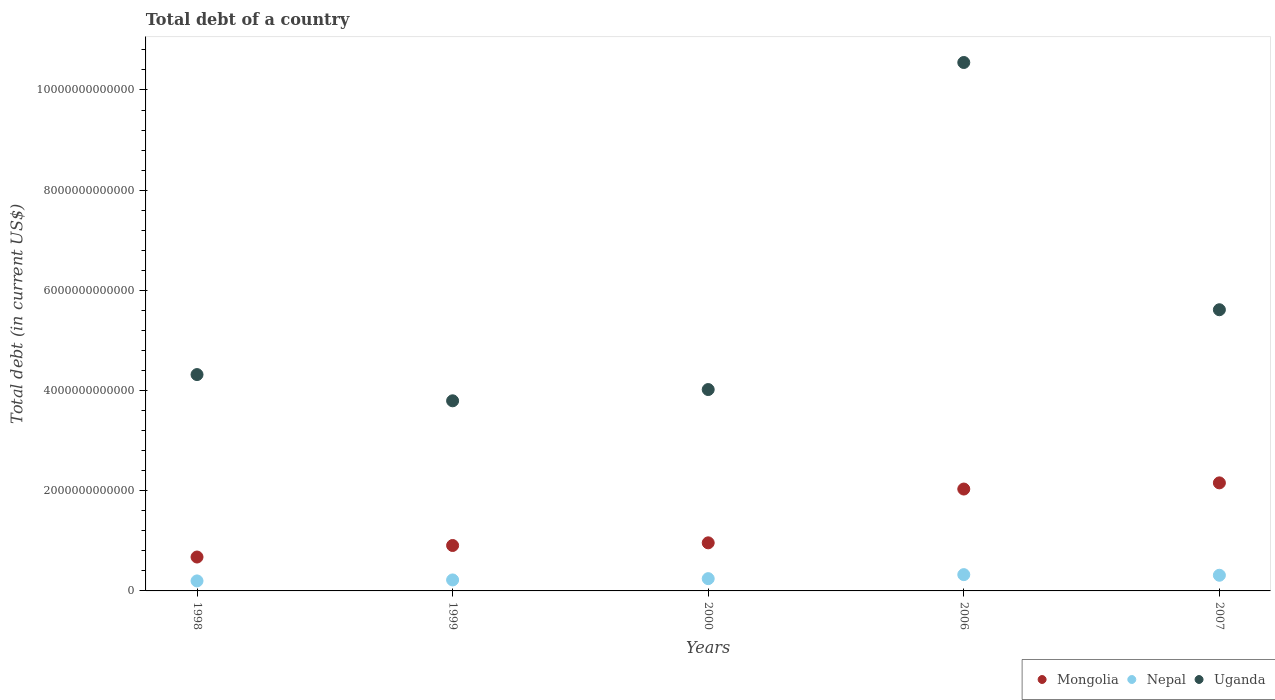Is the number of dotlines equal to the number of legend labels?
Your response must be concise. Yes. What is the debt in Nepal in 1998?
Your response must be concise. 2.00e+11. Across all years, what is the maximum debt in Nepal?
Provide a short and direct response. 3.25e+11. Across all years, what is the minimum debt in Uganda?
Give a very brief answer. 3.79e+12. In which year was the debt in Nepal maximum?
Provide a succinct answer. 2006. What is the total debt in Uganda in the graph?
Make the answer very short. 2.83e+13. What is the difference between the debt in Mongolia in 2000 and that in 2007?
Offer a very short reply. -1.20e+12. What is the difference between the debt in Uganda in 1999 and the debt in Nepal in 2007?
Your answer should be very brief. 3.48e+12. What is the average debt in Uganda per year?
Your response must be concise. 5.66e+12. In the year 1998, what is the difference between the debt in Nepal and debt in Mongolia?
Give a very brief answer. -4.77e+11. What is the ratio of the debt in Uganda in 1999 to that in 2007?
Your answer should be very brief. 0.68. Is the debt in Mongolia in 1999 less than that in 2006?
Provide a succinct answer. Yes. What is the difference between the highest and the second highest debt in Nepal?
Keep it short and to the point. 1.22e+1. What is the difference between the highest and the lowest debt in Mongolia?
Ensure brevity in your answer.  1.48e+12. In how many years, is the debt in Mongolia greater than the average debt in Mongolia taken over all years?
Make the answer very short. 2. Does the debt in Nepal monotonically increase over the years?
Keep it short and to the point. No. Is the debt in Mongolia strictly less than the debt in Nepal over the years?
Provide a succinct answer. No. How many dotlines are there?
Keep it short and to the point. 3. What is the difference between two consecutive major ticks on the Y-axis?
Your answer should be very brief. 2.00e+12. Are the values on the major ticks of Y-axis written in scientific E-notation?
Offer a terse response. No. Does the graph contain grids?
Provide a short and direct response. No. What is the title of the graph?
Ensure brevity in your answer.  Total debt of a country. What is the label or title of the X-axis?
Make the answer very short. Years. What is the label or title of the Y-axis?
Offer a terse response. Total debt (in current US$). What is the Total debt (in current US$) of Mongolia in 1998?
Keep it short and to the point. 6.77e+11. What is the Total debt (in current US$) of Nepal in 1998?
Offer a terse response. 2.00e+11. What is the Total debt (in current US$) of Uganda in 1998?
Keep it short and to the point. 4.32e+12. What is the Total debt (in current US$) of Mongolia in 1999?
Your response must be concise. 9.07e+11. What is the Total debt (in current US$) in Nepal in 1999?
Give a very brief answer. 2.19e+11. What is the Total debt (in current US$) of Uganda in 1999?
Ensure brevity in your answer.  3.79e+12. What is the Total debt (in current US$) in Mongolia in 2000?
Provide a succinct answer. 9.60e+11. What is the Total debt (in current US$) of Nepal in 2000?
Your answer should be very brief. 2.45e+11. What is the Total debt (in current US$) in Uganda in 2000?
Your answer should be very brief. 4.02e+12. What is the Total debt (in current US$) in Mongolia in 2006?
Keep it short and to the point. 2.03e+12. What is the Total debt (in current US$) of Nepal in 2006?
Provide a short and direct response. 3.25e+11. What is the Total debt (in current US$) in Uganda in 2006?
Give a very brief answer. 1.05e+13. What is the Total debt (in current US$) in Mongolia in 2007?
Provide a short and direct response. 2.16e+12. What is the Total debt (in current US$) of Nepal in 2007?
Make the answer very short. 3.13e+11. What is the Total debt (in current US$) of Uganda in 2007?
Provide a succinct answer. 5.61e+12. Across all years, what is the maximum Total debt (in current US$) of Mongolia?
Give a very brief answer. 2.16e+12. Across all years, what is the maximum Total debt (in current US$) of Nepal?
Give a very brief answer. 3.25e+11. Across all years, what is the maximum Total debt (in current US$) in Uganda?
Provide a succinct answer. 1.05e+13. Across all years, what is the minimum Total debt (in current US$) of Mongolia?
Your response must be concise. 6.77e+11. Across all years, what is the minimum Total debt (in current US$) in Nepal?
Your response must be concise. 2.00e+11. Across all years, what is the minimum Total debt (in current US$) in Uganda?
Keep it short and to the point. 3.79e+12. What is the total Total debt (in current US$) in Mongolia in the graph?
Keep it short and to the point. 6.73e+12. What is the total Total debt (in current US$) in Nepal in the graph?
Ensure brevity in your answer.  1.30e+12. What is the total Total debt (in current US$) of Uganda in the graph?
Offer a terse response. 2.83e+13. What is the difference between the Total debt (in current US$) of Mongolia in 1998 and that in 1999?
Provide a succinct answer. -2.30e+11. What is the difference between the Total debt (in current US$) in Nepal in 1998 and that in 1999?
Your response must be concise. -1.95e+1. What is the difference between the Total debt (in current US$) in Uganda in 1998 and that in 1999?
Offer a terse response. 5.24e+11. What is the difference between the Total debt (in current US$) of Mongolia in 1998 and that in 2000?
Ensure brevity in your answer.  -2.83e+11. What is the difference between the Total debt (in current US$) of Nepal in 1998 and that in 2000?
Provide a succinct answer. -4.54e+1. What is the difference between the Total debt (in current US$) of Uganda in 1998 and that in 2000?
Your answer should be compact. 2.99e+11. What is the difference between the Total debt (in current US$) of Mongolia in 1998 and that in 2006?
Keep it short and to the point. -1.36e+12. What is the difference between the Total debt (in current US$) of Nepal in 1998 and that in 2006?
Offer a very short reply. -1.25e+11. What is the difference between the Total debt (in current US$) in Uganda in 1998 and that in 2006?
Keep it short and to the point. -6.23e+12. What is the difference between the Total debt (in current US$) in Mongolia in 1998 and that in 2007?
Offer a very short reply. -1.48e+12. What is the difference between the Total debt (in current US$) in Nepal in 1998 and that in 2007?
Make the answer very short. -1.13e+11. What is the difference between the Total debt (in current US$) in Uganda in 1998 and that in 2007?
Offer a very short reply. -1.29e+12. What is the difference between the Total debt (in current US$) of Mongolia in 1999 and that in 2000?
Give a very brief answer. -5.32e+1. What is the difference between the Total debt (in current US$) of Nepal in 1999 and that in 2000?
Offer a terse response. -2.59e+1. What is the difference between the Total debt (in current US$) in Uganda in 1999 and that in 2000?
Your answer should be compact. -2.25e+11. What is the difference between the Total debt (in current US$) of Mongolia in 1999 and that in 2006?
Keep it short and to the point. -1.13e+12. What is the difference between the Total debt (in current US$) of Nepal in 1999 and that in 2006?
Offer a terse response. -1.06e+11. What is the difference between the Total debt (in current US$) in Uganda in 1999 and that in 2006?
Your answer should be compact. -6.75e+12. What is the difference between the Total debt (in current US$) of Mongolia in 1999 and that in 2007?
Give a very brief answer. -1.25e+12. What is the difference between the Total debt (in current US$) of Nepal in 1999 and that in 2007?
Make the answer very short. -9.37e+1. What is the difference between the Total debt (in current US$) in Uganda in 1999 and that in 2007?
Offer a very short reply. -1.82e+12. What is the difference between the Total debt (in current US$) in Mongolia in 2000 and that in 2006?
Your answer should be very brief. -1.07e+12. What is the difference between the Total debt (in current US$) in Nepal in 2000 and that in 2006?
Offer a terse response. -7.99e+1. What is the difference between the Total debt (in current US$) of Uganda in 2000 and that in 2006?
Ensure brevity in your answer.  -6.53e+12. What is the difference between the Total debt (in current US$) in Mongolia in 2000 and that in 2007?
Ensure brevity in your answer.  -1.20e+12. What is the difference between the Total debt (in current US$) of Nepal in 2000 and that in 2007?
Offer a terse response. -6.78e+1. What is the difference between the Total debt (in current US$) of Uganda in 2000 and that in 2007?
Provide a succinct answer. -1.59e+12. What is the difference between the Total debt (in current US$) of Mongolia in 2006 and that in 2007?
Keep it short and to the point. -1.23e+11. What is the difference between the Total debt (in current US$) in Nepal in 2006 and that in 2007?
Your response must be concise. 1.22e+1. What is the difference between the Total debt (in current US$) of Uganda in 2006 and that in 2007?
Provide a succinct answer. 4.94e+12. What is the difference between the Total debt (in current US$) of Mongolia in 1998 and the Total debt (in current US$) of Nepal in 1999?
Provide a succinct answer. 4.58e+11. What is the difference between the Total debt (in current US$) of Mongolia in 1998 and the Total debt (in current US$) of Uganda in 1999?
Offer a very short reply. -3.12e+12. What is the difference between the Total debt (in current US$) in Nepal in 1998 and the Total debt (in current US$) in Uganda in 1999?
Give a very brief answer. -3.60e+12. What is the difference between the Total debt (in current US$) of Mongolia in 1998 and the Total debt (in current US$) of Nepal in 2000?
Offer a terse response. 4.32e+11. What is the difference between the Total debt (in current US$) in Mongolia in 1998 and the Total debt (in current US$) in Uganda in 2000?
Provide a short and direct response. -3.34e+12. What is the difference between the Total debt (in current US$) in Nepal in 1998 and the Total debt (in current US$) in Uganda in 2000?
Your answer should be very brief. -3.82e+12. What is the difference between the Total debt (in current US$) of Mongolia in 1998 and the Total debt (in current US$) of Nepal in 2006?
Provide a short and direct response. 3.52e+11. What is the difference between the Total debt (in current US$) in Mongolia in 1998 and the Total debt (in current US$) in Uganda in 2006?
Your response must be concise. -9.87e+12. What is the difference between the Total debt (in current US$) in Nepal in 1998 and the Total debt (in current US$) in Uganda in 2006?
Your answer should be very brief. -1.03e+13. What is the difference between the Total debt (in current US$) of Mongolia in 1998 and the Total debt (in current US$) of Nepal in 2007?
Make the answer very short. 3.64e+11. What is the difference between the Total debt (in current US$) of Mongolia in 1998 and the Total debt (in current US$) of Uganda in 2007?
Make the answer very short. -4.94e+12. What is the difference between the Total debt (in current US$) in Nepal in 1998 and the Total debt (in current US$) in Uganda in 2007?
Offer a very short reply. -5.41e+12. What is the difference between the Total debt (in current US$) of Mongolia in 1999 and the Total debt (in current US$) of Nepal in 2000?
Provide a succinct answer. 6.62e+11. What is the difference between the Total debt (in current US$) in Mongolia in 1999 and the Total debt (in current US$) in Uganda in 2000?
Offer a terse response. -3.11e+12. What is the difference between the Total debt (in current US$) of Nepal in 1999 and the Total debt (in current US$) of Uganda in 2000?
Offer a very short reply. -3.80e+12. What is the difference between the Total debt (in current US$) of Mongolia in 1999 and the Total debt (in current US$) of Nepal in 2006?
Keep it short and to the point. 5.82e+11. What is the difference between the Total debt (in current US$) of Mongolia in 1999 and the Total debt (in current US$) of Uganda in 2006?
Your answer should be compact. -9.64e+12. What is the difference between the Total debt (in current US$) in Nepal in 1999 and the Total debt (in current US$) in Uganda in 2006?
Offer a terse response. -1.03e+13. What is the difference between the Total debt (in current US$) of Mongolia in 1999 and the Total debt (in current US$) of Nepal in 2007?
Make the answer very short. 5.94e+11. What is the difference between the Total debt (in current US$) of Mongolia in 1999 and the Total debt (in current US$) of Uganda in 2007?
Provide a succinct answer. -4.71e+12. What is the difference between the Total debt (in current US$) in Nepal in 1999 and the Total debt (in current US$) in Uganda in 2007?
Give a very brief answer. -5.39e+12. What is the difference between the Total debt (in current US$) of Mongolia in 2000 and the Total debt (in current US$) of Nepal in 2006?
Your answer should be very brief. 6.35e+11. What is the difference between the Total debt (in current US$) of Mongolia in 2000 and the Total debt (in current US$) of Uganda in 2006?
Offer a very short reply. -9.59e+12. What is the difference between the Total debt (in current US$) in Nepal in 2000 and the Total debt (in current US$) in Uganda in 2006?
Make the answer very short. -1.03e+13. What is the difference between the Total debt (in current US$) of Mongolia in 2000 and the Total debt (in current US$) of Nepal in 2007?
Provide a succinct answer. 6.47e+11. What is the difference between the Total debt (in current US$) of Mongolia in 2000 and the Total debt (in current US$) of Uganda in 2007?
Your answer should be very brief. -4.65e+12. What is the difference between the Total debt (in current US$) of Nepal in 2000 and the Total debt (in current US$) of Uganda in 2007?
Make the answer very short. -5.37e+12. What is the difference between the Total debt (in current US$) in Mongolia in 2006 and the Total debt (in current US$) in Nepal in 2007?
Your answer should be compact. 1.72e+12. What is the difference between the Total debt (in current US$) of Mongolia in 2006 and the Total debt (in current US$) of Uganda in 2007?
Make the answer very short. -3.58e+12. What is the difference between the Total debt (in current US$) in Nepal in 2006 and the Total debt (in current US$) in Uganda in 2007?
Offer a very short reply. -5.29e+12. What is the average Total debt (in current US$) in Mongolia per year?
Keep it short and to the point. 1.35e+12. What is the average Total debt (in current US$) in Nepal per year?
Ensure brevity in your answer.  2.60e+11. What is the average Total debt (in current US$) of Uganda per year?
Give a very brief answer. 5.66e+12. In the year 1998, what is the difference between the Total debt (in current US$) of Mongolia and Total debt (in current US$) of Nepal?
Provide a short and direct response. 4.77e+11. In the year 1998, what is the difference between the Total debt (in current US$) of Mongolia and Total debt (in current US$) of Uganda?
Make the answer very short. -3.64e+12. In the year 1998, what is the difference between the Total debt (in current US$) of Nepal and Total debt (in current US$) of Uganda?
Your answer should be very brief. -4.12e+12. In the year 1999, what is the difference between the Total debt (in current US$) in Mongolia and Total debt (in current US$) in Nepal?
Your answer should be very brief. 6.88e+11. In the year 1999, what is the difference between the Total debt (in current US$) of Mongolia and Total debt (in current US$) of Uganda?
Your answer should be very brief. -2.89e+12. In the year 1999, what is the difference between the Total debt (in current US$) of Nepal and Total debt (in current US$) of Uganda?
Provide a succinct answer. -3.58e+12. In the year 2000, what is the difference between the Total debt (in current US$) in Mongolia and Total debt (in current US$) in Nepal?
Offer a terse response. 7.15e+11. In the year 2000, what is the difference between the Total debt (in current US$) of Mongolia and Total debt (in current US$) of Uganda?
Provide a succinct answer. -3.06e+12. In the year 2000, what is the difference between the Total debt (in current US$) of Nepal and Total debt (in current US$) of Uganda?
Give a very brief answer. -3.77e+12. In the year 2006, what is the difference between the Total debt (in current US$) in Mongolia and Total debt (in current US$) in Nepal?
Make the answer very short. 1.71e+12. In the year 2006, what is the difference between the Total debt (in current US$) of Mongolia and Total debt (in current US$) of Uganda?
Offer a very short reply. -8.51e+12. In the year 2006, what is the difference between the Total debt (in current US$) in Nepal and Total debt (in current US$) in Uganda?
Make the answer very short. -1.02e+13. In the year 2007, what is the difference between the Total debt (in current US$) in Mongolia and Total debt (in current US$) in Nepal?
Provide a succinct answer. 1.84e+12. In the year 2007, what is the difference between the Total debt (in current US$) in Mongolia and Total debt (in current US$) in Uganda?
Keep it short and to the point. -3.46e+12. In the year 2007, what is the difference between the Total debt (in current US$) of Nepal and Total debt (in current US$) of Uganda?
Keep it short and to the point. -5.30e+12. What is the ratio of the Total debt (in current US$) of Mongolia in 1998 to that in 1999?
Offer a very short reply. 0.75. What is the ratio of the Total debt (in current US$) in Nepal in 1998 to that in 1999?
Ensure brevity in your answer.  0.91. What is the ratio of the Total debt (in current US$) of Uganda in 1998 to that in 1999?
Provide a succinct answer. 1.14. What is the ratio of the Total debt (in current US$) of Mongolia in 1998 to that in 2000?
Provide a succinct answer. 0.7. What is the ratio of the Total debt (in current US$) of Nepal in 1998 to that in 2000?
Offer a very short reply. 0.81. What is the ratio of the Total debt (in current US$) in Uganda in 1998 to that in 2000?
Your answer should be very brief. 1.07. What is the ratio of the Total debt (in current US$) in Mongolia in 1998 to that in 2006?
Make the answer very short. 0.33. What is the ratio of the Total debt (in current US$) of Nepal in 1998 to that in 2006?
Your answer should be compact. 0.61. What is the ratio of the Total debt (in current US$) in Uganda in 1998 to that in 2006?
Your answer should be very brief. 0.41. What is the ratio of the Total debt (in current US$) in Mongolia in 1998 to that in 2007?
Offer a very short reply. 0.31. What is the ratio of the Total debt (in current US$) in Nepal in 1998 to that in 2007?
Offer a terse response. 0.64. What is the ratio of the Total debt (in current US$) of Uganda in 1998 to that in 2007?
Provide a succinct answer. 0.77. What is the ratio of the Total debt (in current US$) in Mongolia in 1999 to that in 2000?
Your answer should be very brief. 0.94. What is the ratio of the Total debt (in current US$) of Nepal in 1999 to that in 2000?
Make the answer very short. 0.89. What is the ratio of the Total debt (in current US$) in Uganda in 1999 to that in 2000?
Provide a succinct answer. 0.94. What is the ratio of the Total debt (in current US$) of Mongolia in 1999 to that in 2006?
Provide a short and direct response. 0.45. What is the ratio of the Total debt (in current US$) in Nepal in 1999 to that in 2006?
Your response must be concise. 0.67. What is the ratio of the Total debt (in current US$) in Uganda in 1999 to that in 2006?
Give a very brief answer. 0.36. What is the ratio of the Total debt (in current US$) in Mongolia in 1999 to that in 2007?
Keep it short and to the point. 0.42. What is the ratio of the Total debt (in current US$) in Nepal in 1999 to that in 2007?
Your answer should be very brief. 0.7. What is the ratio of the Total debt (in current US$) in Uganda in 1999 to that in 2007?
Your answer should be very brief. 0.68. What is the ratio of the Total debt (in current US$) of Mongolia in 2000 to that in 2006?
Provide a succinct answer. 0.47. What is the ratio of the Total debt (in current US$) in Nepal in 2000 to that in 2006?
Your answer should be very brief. 0.75. What is the ratio of the Total debt (in current US$) in Uganda in 2000 to that in 2006?
Provide a succinct answer. 0.38. What is the ratio of the Total debt (in current US$) of Mongolia in 2000 to that in 2007?
Provide a short and direct response. 0.45. What is the ratio of the Total debt (in current US$) of Nepal in 2000 to that in 2007?
Your answer should be very brief. 0.78. What is the ratio of the Total debt (in current US$) in Uganda in 2000 to that in 2007?
Keep it short and to the point. 0.72. What is the ratio of the Total debt (in current US$) of Mongolia in 2006 to that in 2007?
Your answer should be very brief. 0.94. What is the ratio of the Total debt (in current US$) of Nepal in 2006 to that in 2007?
Keep it short and to the point. 1.04. What is the ratio of the Total debt (in current US$) of Uganda in 2006 to that in 2007?
Provide a short and direct response. 1.88. What is the difference between the highest and the second highest Total debt (in current US$) of Mongolia?
Provide a short and direct response. 1.23e+11. What is the difference between the highest and the second highest Total debt (in current US$) in Nepal?
Your answer should be very brief. 1.22e+1. What is the difference between the highest and the second highest Total debt (in current US$) of Uganda?
Keep it short and to the point. 4.94e+12. What is the difference between the highest and the lowest Total debt (in current US$) of Mongolia?
Offer a terse response. 1.48e+12. What is the difference between the highest and the lowest Total debt (in current US$) in Nepal?
Provide a short and direct response. 1.25e+11. What is the difference between the highest and the lowest Total debt (in current US$) of Uganda?
Make the answer very short. 6.75e+12. 